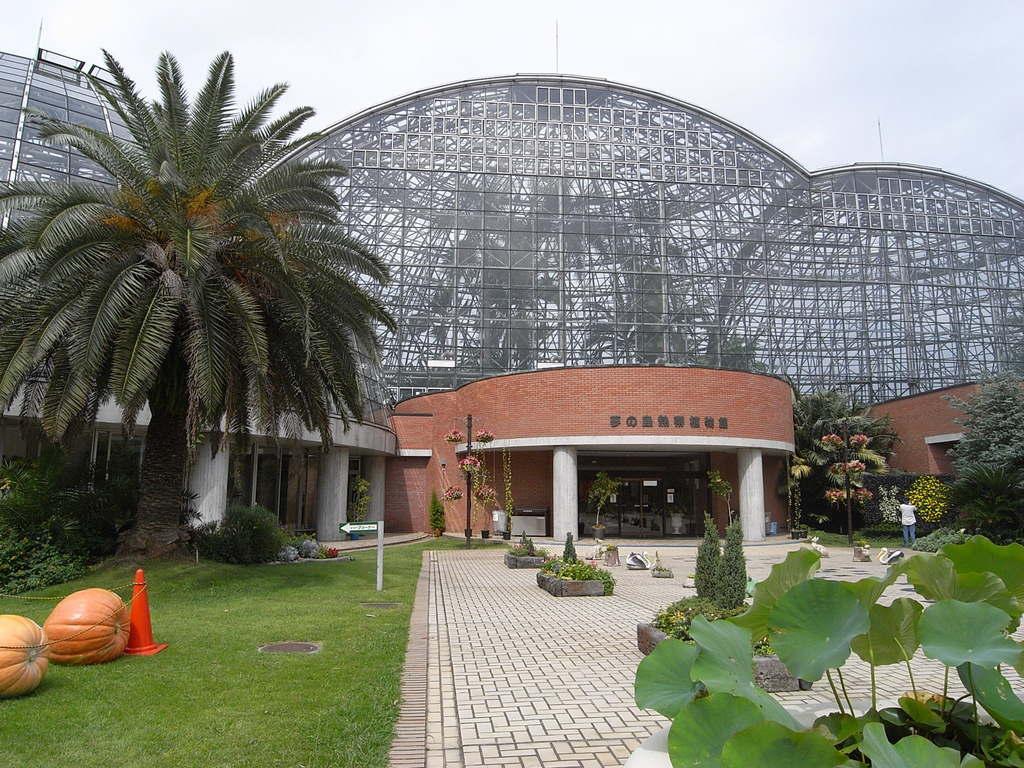How would you summarize this image in a sentence or two? In this image I can see grass and number of plants in the front. In the background I can see few buildings, few trees and the sky. In the centre of this image I can see something is written on the building. On the left side of this image I can see few orange colour things, few poles and an orange colour cone. On the right side of this image I can see a person is standing. 